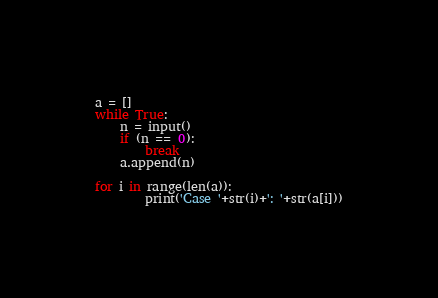Convert code to text. <code><loc_0><loc_0><loc_500><loc_500><_Python_>a = []
while True:
    n = input()
    if (n == 0):
        break
    a.append(n)

for i in range(len(a)):
        print('Case '+str(i)+': '+str(a[i]))</code> 